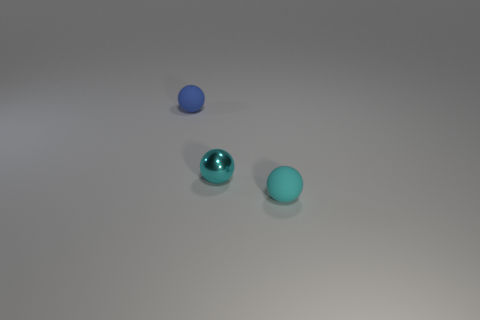Subtract all tiny cyan balls. How many balls are left? 1 Subtract all blue balls. How many balls are left? 2 Subtract 1 spheres. How many spheres are left? 2 Add 1 spheres. How many objects exist? 4 Add 3 balls. How many balls exist? 6 Subtract 2 cyan balls. How many objects are left? 1 Subtract all blue spheres. Subtract all blue cylinders. How many spheres are left? 2 Subtract all gray cylinders. How many blue balls are left? 1 Subtract all tiny shiny balls. Subtract all tiny blue objects. How many objects are left? 1 Add 1 matte objects. How many matte objects are left? 3 